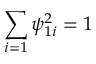Convert formula to latex. <formula><loc_0><loc_0><loc_500><loc_500>\sum _ { i = 1 } \psi _ { 1 i } ^ { 2 } = 1</formula> 